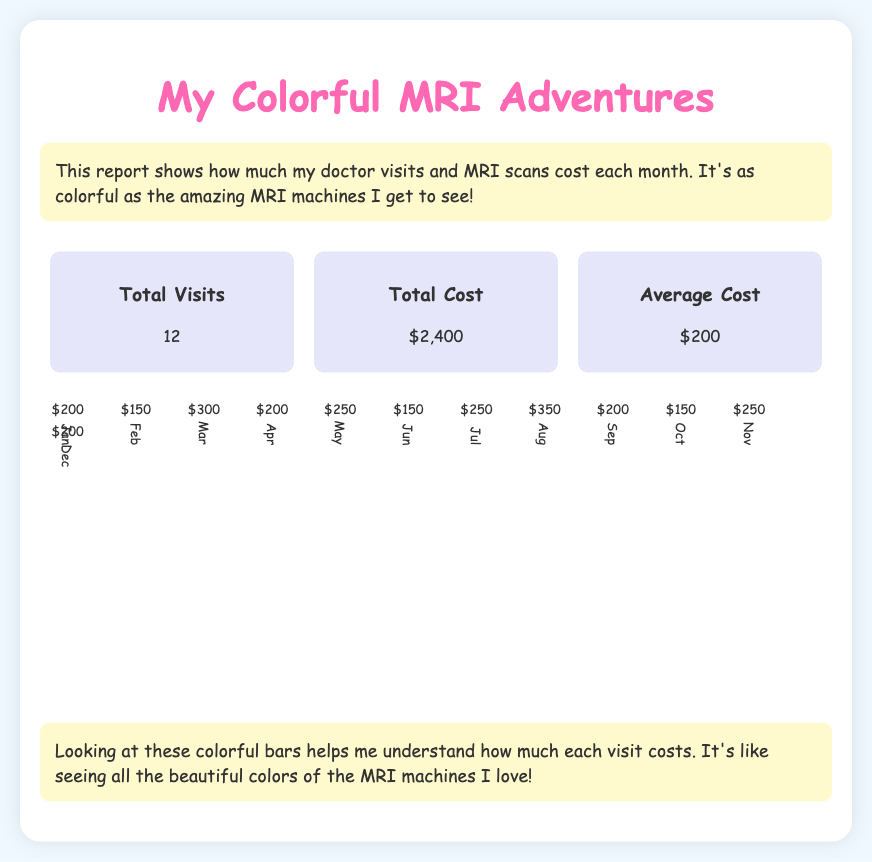how many total visits were there? The total visits are summarized in the section of the document that lists total metrics, which states 12.
Answer: 12 what was the total cost for the MRI scans? The total cost is provided in the summary section of the document, indicating $2,400.
Answer: $2,400 what is the average cost per visit? The average cost is explicitly mentioned in the summary section as $200.
Answer: $200 in which month was the highest cost incurred? The document presents monthly costs in a chart, with August showing the highest cost of $350.
Answer: August how much did the doctor visits cost in March? The document states that the cost for March was $300, which is indicated in the chart.
Answer: $300 which month had the lowest cost for MRI visits? According to the monthly cost chart, February shows the lowest cost at $150.
Answer: February what color represents the costs in June? The bar for June is displayed in peachpuff, as indicated in the chart section.
Answer: peachpuff how many months cost more than $200? By analyzing the chart, we see that four months had costs exceeding $200: March, May, August, and November.
Answer: 4 what is the purpose of the report? The introduction states that the report shows the costs of doctor visits and MRI scans in a colorful manner, reflecting the child's love for the designs.
Answer: show costs 